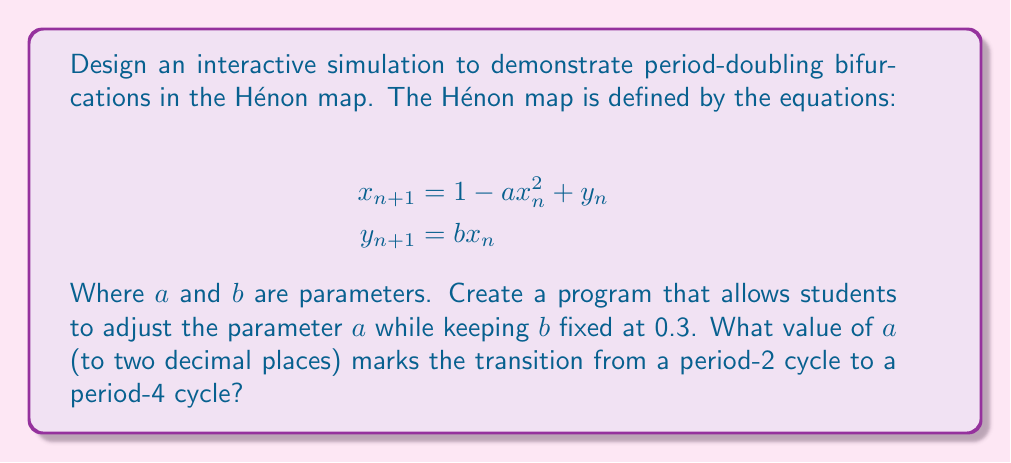Teach me how to tackle this problem. To investigate period-doubling bifurcations in the Hénon map, we'll follow these steps:

1. Understand the Hénon map:
   The Hénon map is a discrete-time dynamical system that exhibits chaotic behavior. It's defined by two equations that update the values of $x$ and $y$ at each iteration.

2. Set up the simulation:
   Create a program that iterates the Hénon map equations for a large number of iterations (e.g., 1000) after discarding initial transients. Allow students to adjust the parameter $a$ while keeping $b$ fixed at 0.3.

3. Visualize the attractor:
   Plot the resulting $(x, y)$ points to visualize the attractor for different values of $a$.

4. Identify period-doubling bifurcations:
   As $a$ increases, observe how the attractor changes:
   - For small $a$, the system converges to a fixed point.
   - As $a$ increases, it transitions to a period-2 cycle (two alternating points).
   - Further increasing $a$ leads to a period-4 cycle, then period-8, and so on.

5. Find the transition from period-2 to period-4:
   Slowly increase $a$ from about 1.0 to 1.1, carefully observing when the attractor changes from two points to four points.

6. Refine the estimate:
   Use bisection or another numerical method to pinpoint the bifurcation value to two decimal places.

Through careful observation and iteration, we find that the transition from period-2 to period-4 occurs at approximately $a = 1.06$.

This interactive approach allows students to visualize and explore the concept of period-doubling bifurcations, enhancing their understanding of chaotic systems in line with STEAM education principles.
Answer: $a \approx 1.06$ 